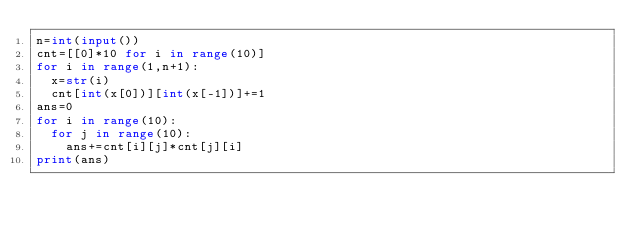Convert code to text. <code><loc_0><loc_0><loc_500><loc_500><_Python_>n=int(input())
cnt=[[0]*10 for i in range(10)]
for i in range(1,n+1):
  x=str(i)
  cnt[int(x[0])][int(x[-1])]+=1
ans=0
for i in range(10):
  for j in range(10):
    ans+=cnt[i][j]*cnt[j][i]
print(ans)</code> 